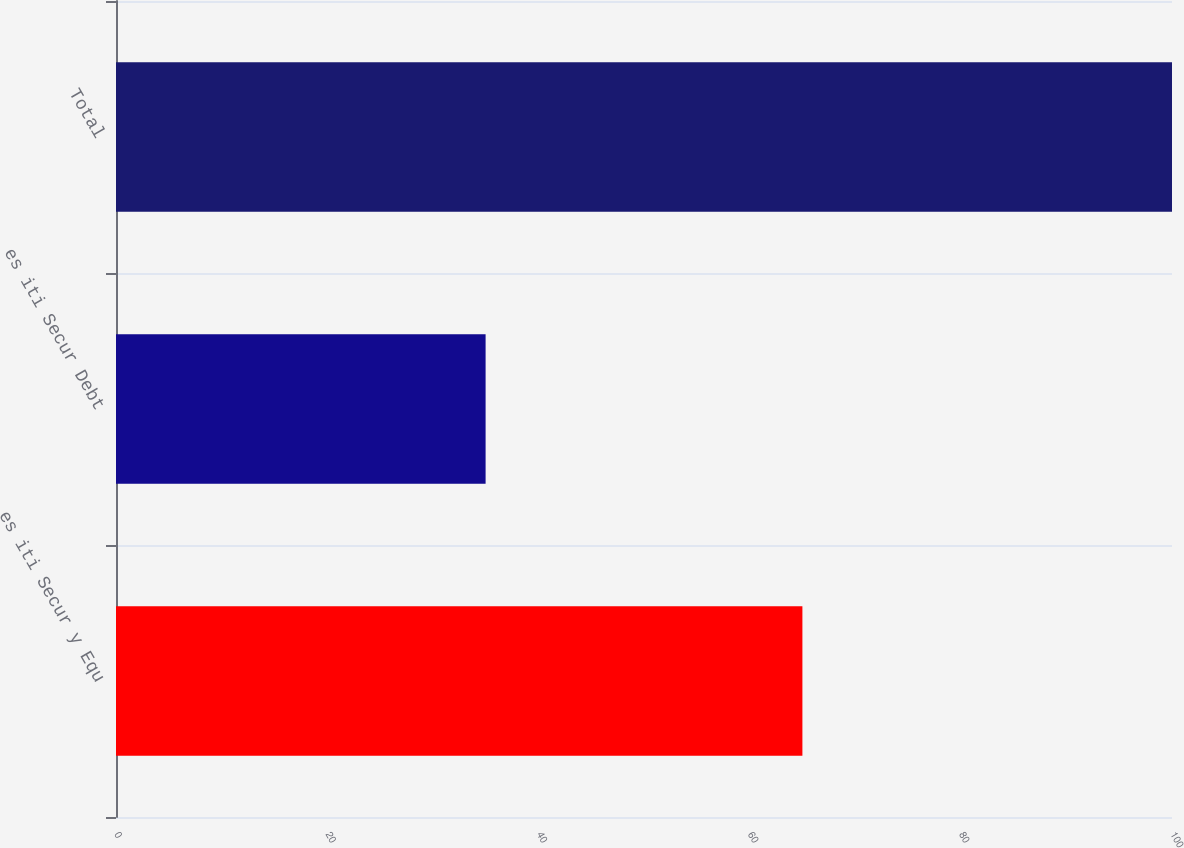<chart> <loc_0><loc_0><loc_500><loc_500><bar_chart><fcel>es iti Secur y Equ<fcel>es iti Secur Debt<fcel>Total<nl><fcel>65<fcel>35<fcel>100<nl></chart> 